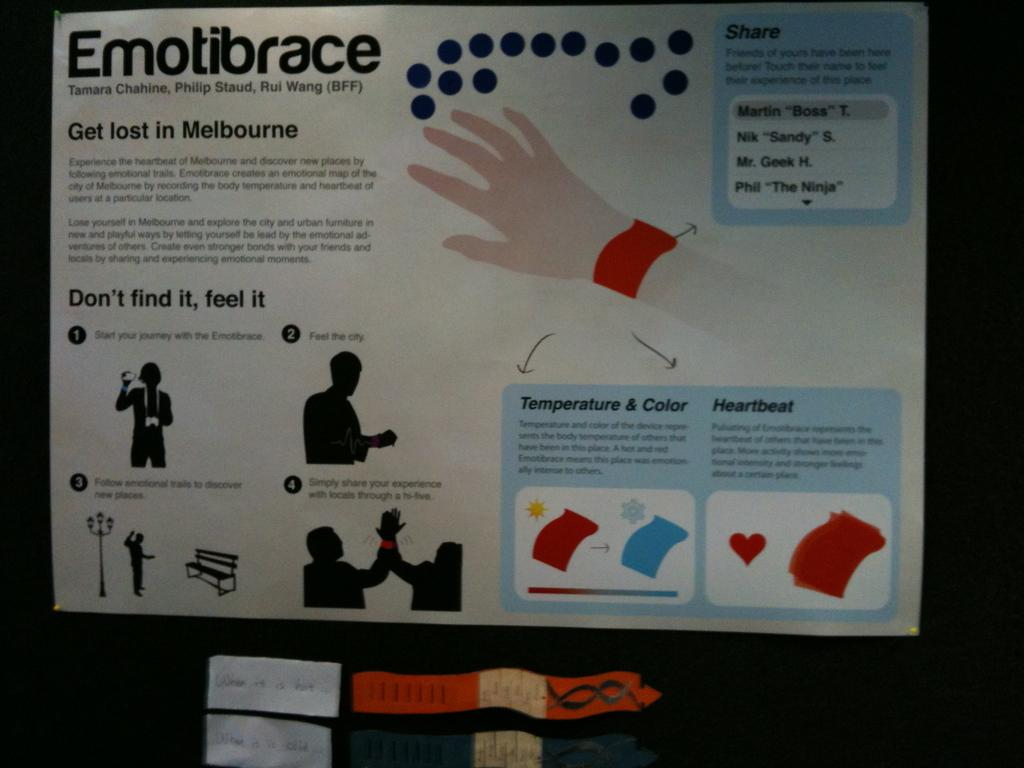<image>
Present a compact description of the photo's key features. Emotibrace says to get lost in Melbourne.and don't find it, feel it. 